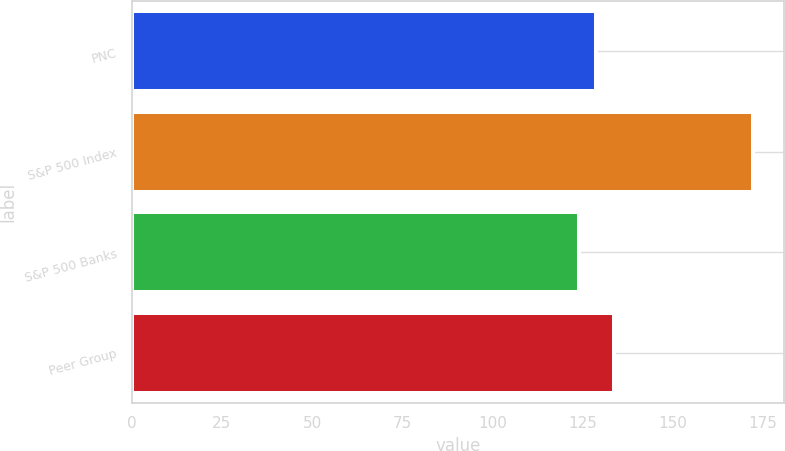Convert chart. <chart><loc_0><loc_0><loc_500><loc_500><bar_chart><fcel>PNC<fcel>S&P 500 Index<fcel>S&P 500 Banks<fcel>Peer Group<nl><fcel>128.82<fcel>172.31<fcel>123.99<fcel>133.65<nl></chart> 